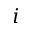Convert formula to latex. <formula><loc_0><loc_0><loc_500><loc_500>i</formula> 